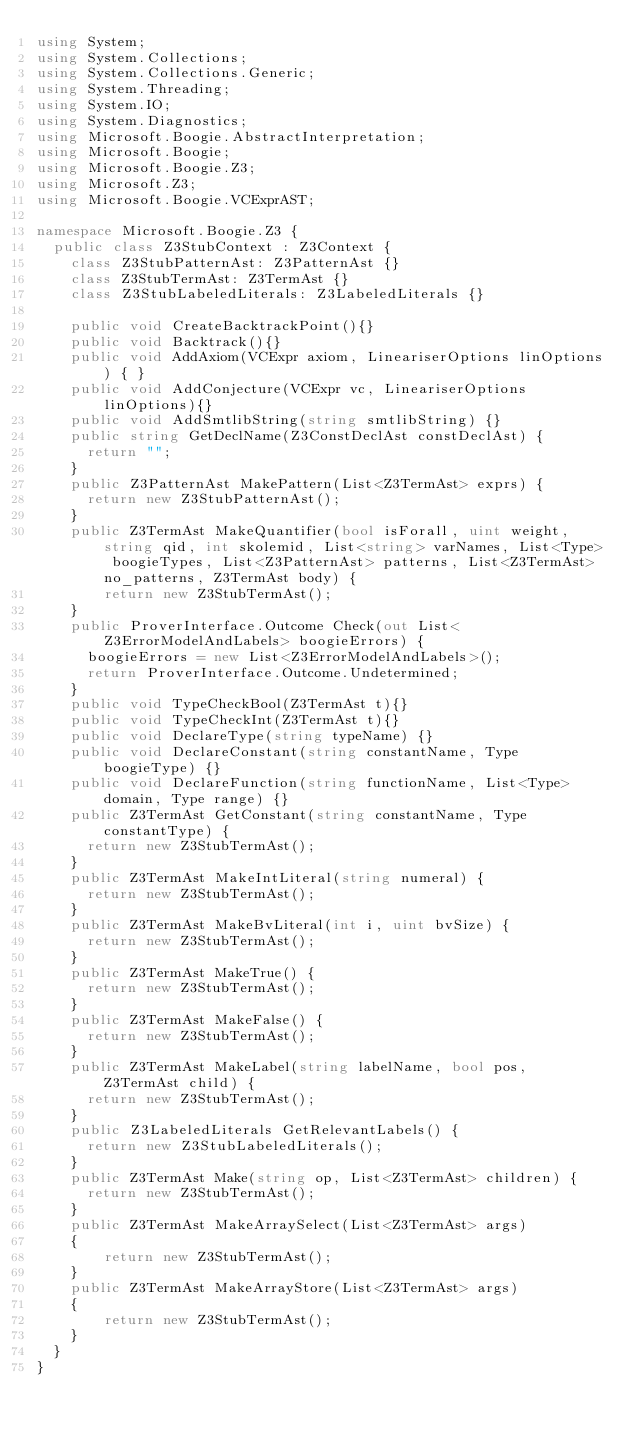<code> <loc_0><loc_0><loc_500><loc_500><_C#_>using System;
using System.Collections;
using System.Collections.Generic;
using System.Threading;
using System.IO;
using System.Diagnostics;
using Microsoft.Boogie.AbstractInterpretation;
using Microsoft.Boogie;
using Microsoft.Boogie.Z3;
using Microsoft.Z3;
using Microsoft.Boogie.VCExprAST;

namespace Microsoft.Boogie.Z3 {
  public class Z3StubContext : Z3Context {
    class Z3StubPatternAst: Z3PatternAst {}
    class Z3StubTermAst: Z3TermAst {}
    class Z3StubLabeledLiterals: Z3LabeledLiterals {}
  
    public void CreateBacktrackPoint(){}
    public void Backtrack(){}
    public void AddAxiom(VCExpr axiom, LineariserOptions linOptions) { }
    public void AddConjecture(VCExpr vc, LineariserOptions linOptions){}
    public void AddSmtlibString(string smtlibString) {}
    public string GetDeclName(Z3ConstDeclAst constDeclAst) {
      return "";
    }
    public Z3PatternAst MakePattern(List<Z3TermAst> exprs) {
      return new Z3StubPatternAst();
    }
    public Z3TermAst MakeQuantifier(bool isForall, uint weight, string qid, int skolemid, List<string> varNames, List<Type> boogieTypes, List<Z3PatternAst> patterns, List<Z3TermAst> no_patterns, Z3TermAst body) {
        return new Z3StubTermAst();
    }
    public ProverInterface.Outcome Check(out List<Z3ErrorModelAndLabels> boogieErrors) {
      boogieErrors = new List<Z3ErrorModelAndLabels>();
      return ProverInterface.Outcome.Undetermined;
    }
    public void TypeCheckBool(Z3TermAst t){}
    public void TypeCheckInt(Z3TermAst t){}
    public void DeclareType(string typeName) {}
    public void DeclareConstant(string constantName, Type boogieType) {}
    public void DeclareFunction(string functionName, List<Type> domain, Type range) {}
    public Z3TermAst GetConstant(string constantName, Type constantType) {
      return new Z3StubTermAst();
    }    
    public Z3TermAst MakeIntLiteral(string numeral) {
      return new Z3StubTermAst();
    }
    public Z3TermAst MakeBvLiteral(int i, uint bvSize) {
      return new Z3StubTermAst();
    }
    public Z3TermAst MakeTrue() {
      return new Z3StubTermAst();
    }
    public Z3TermAst MakeFalse() {
      return new Z3StubTermAst();
    }
    public Z3TermAst MakeLabel(string labelName, bool pos, Z3TermAst child) {
      return new Z3StubTermAst();
    }
    public Z3LabeledLiterals GetRelevantLabels() {
      return new Z3StubLabeledLiterals();
    }
    public Z3TermAst Make(string op, List<Z3TermAst> children) {
      return new Z3StubTermAst();
    }
    public Z3TermAst MakeArraySelect(List<Z3TermAst> args)
    {
        return new Z3StubTermAst();
    }
    public Z3TermAst MakeArrayStore(List<Z3TermAst> args)
    {
        return new Z3StubTermAst();
    }
  }
}</code> 